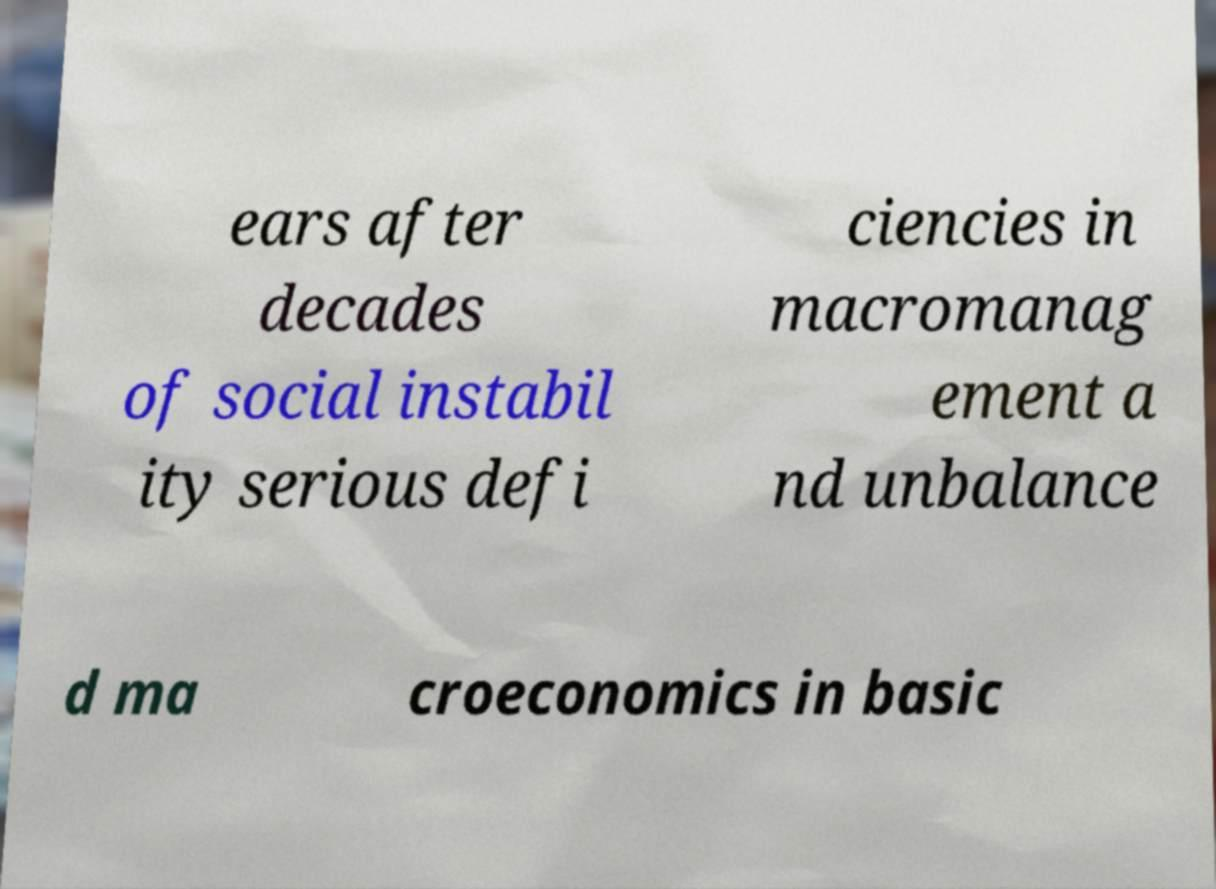Could you assist in decoding the text presented in this image and type it out clearly? ears after decades of social instabil ity serious defi ciencies in macromanag ement a nd unbalance d ma croeconomics in basic 